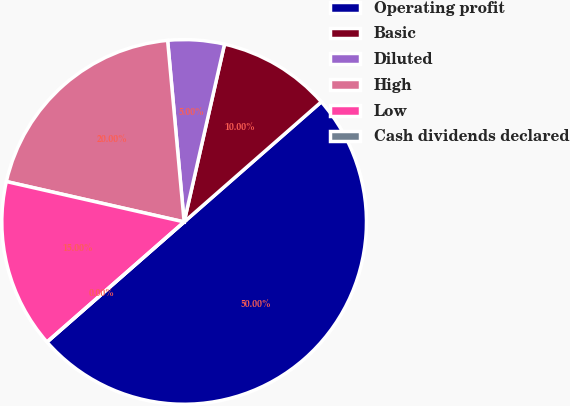Convert chart. <chart><loc_0><loc_0><loc_500><loc_500><pie_chart><fcel>Operating profit<fcel>Basic<fcel>Diluted<fcel>High<fcel>Low<fcel>Cash dividends declared<nl><fcel>50.0%<fcel>10.0%<fcel>5.0%<fcel>20.0%<fcel>15.0%<fcel>0.0%<nl></chart> 